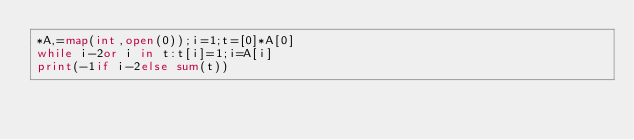<code> <loc_0><loc_0><loc_500><loc_500><_Python_>*A,=map(int,open(0));i=1;t=[0]*A[0]
while i-2or i in t:t[i]=1;i=A[i]
print(-1if i-2else sum(t))</code> 